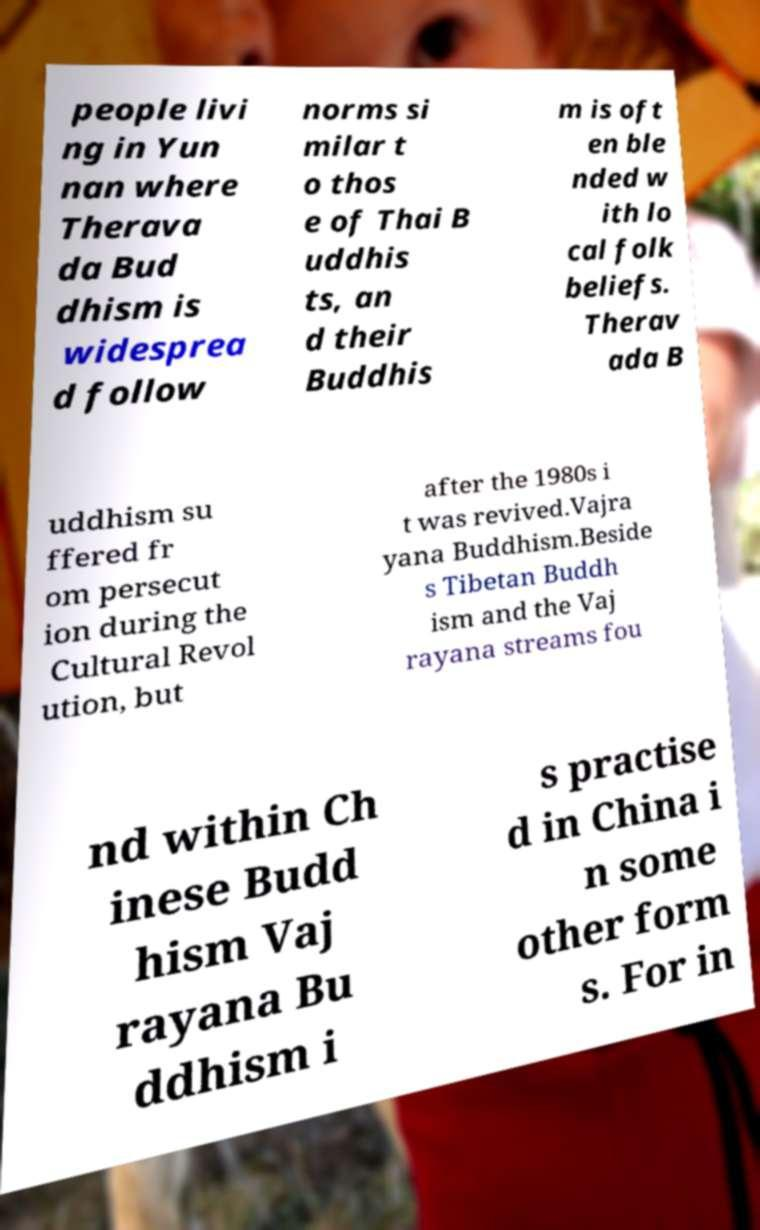Could you assist in decoding the text presented in this image and type it out clearly? people livi ng in Yun nan where Therava da Bud dhism is widesprea d follow norms si milar t o thos e of Thai B uddhis ts, an d their Buddhis m is oft en ble nded w ith lo cal folk beliefs. Therav ada B uddhism su ffered fr om persecut ion during the Cultural Revol ution, but after the 1980s i t was revived.Vajra yana Buddhism.Beside s Tibetan Buddh ism and the Vaj rayana streams fou nd within Ch inese Budd hism Vaj rayana Bu ddhism i s practise d in China i n some other form s. For in 